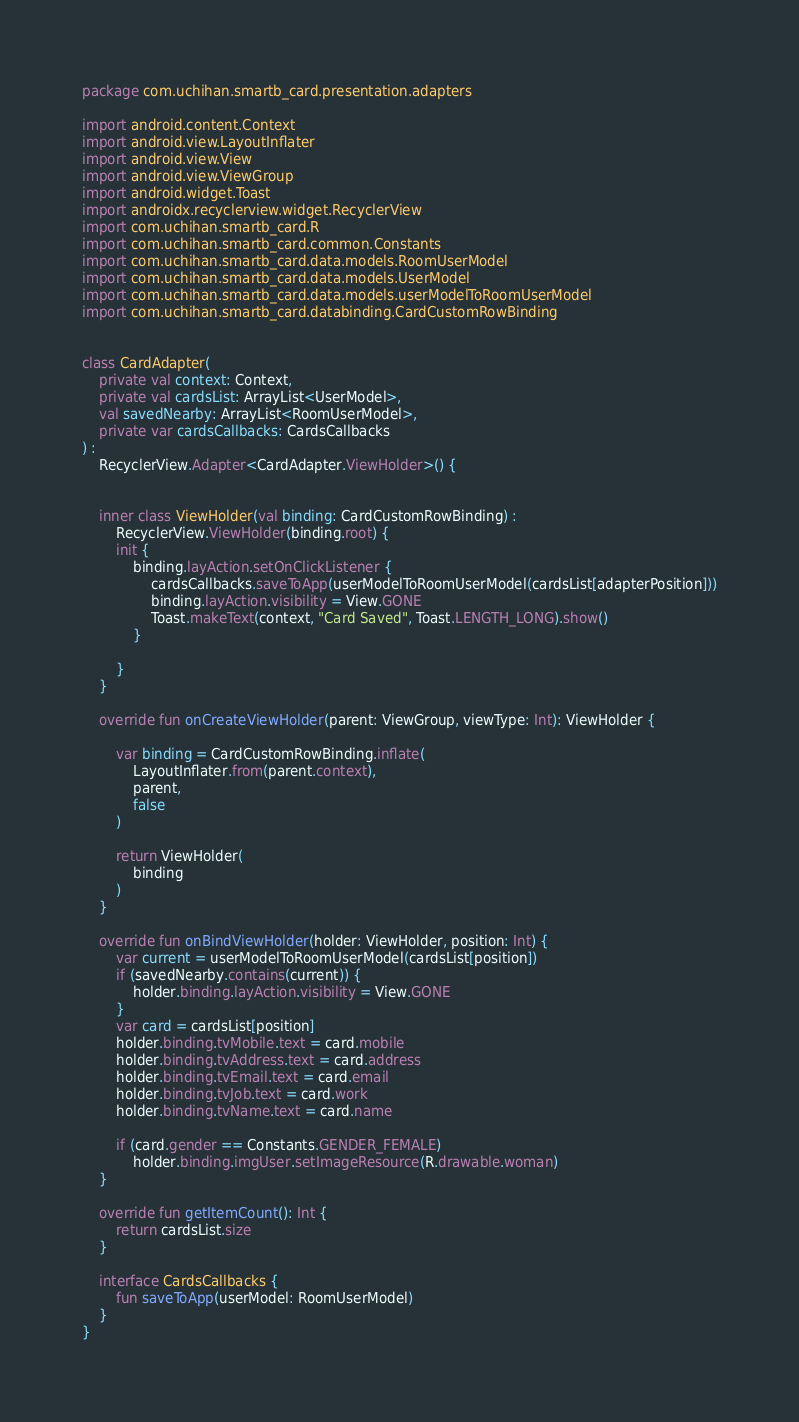<code> <loc_0><loc_0><loc_500><loc_500><_Kotlin_>package com.uchihan.smartb_card.presentation.adapters

import android.content.Context
import android.view.LayoutInflater
import android.view.View
import android.view.ViewGroup
import android.widget.Toast
import androidx.recyclerview.widget.RecyclerView
import com.uchihan.smartb_card.R
import com.uchihan.smartb_card.common.Constants
import com.uchihan.smartb_card.data.models.RoomUserModel
import com.uchihan.smartb_card.data.models.UserModel
import com.uchihan.smartb_card.data.models.userModelToRoomUserModel
import com.uchihan.smartb_card.databinding.CardCustomRowBinding


class CardAdapter(
    private val context: Context,
    private val cardsList: ArrayList<UserModel>,
    val savedNearby: ArrayList<RoomUserModel>,
    private var cardsCallbacks: CardsCallbacks
) :
    RecyclerView.Adapter<CardAdapter.ViewHolder>() {


    inner class ViewHolder(val binding: CardCustomRowBinding) :
        RecyclerView.ViewHolder(binding.root) {
        init {
            binding.layAction.setOnClickListener {
                cardsCallbacks.saveToApp(userModelToRoomUserModel(cardsList[adapterPosition]))
                binding.layAction.visibility = View.GONE
                Toast.makeText(context, "Card Saved", Toast.LENGTH_LONG).show()
            }

        }
    }

    override fun onCreateViewHolder(parent: ViewGroup, viewType: Int): ViewHolder {

        var binding = CardCustomRowBinding.inflate(
            LayoutInflater.from(parent.context),
            parent,
            false
        )

        return ViewHolder(
            binding
        )
    }

    override fun onBindViewHolder(holder: ViewHolder, position: Int) {
        var current = userModelToRoomUserModel(cardsList[position])
        if (savedNearby.contains(current)) {
            holder.binding.layAction.visibility = View.GONE
        }
        var card = cardsList[position]
        holder.binding.tvMobile.text = card.mobile
        holder.binding.tvAddress.text = card.address
        holder.binding.tvEmail.text = card.email
        holder.binding.tvJob.text = card.work
        holder.binding.tvName.text = card.name

        if (card.gender == Constants.GENDER_FEMALE)
            holder.binding.imgUser.setImageResource(R.drawable.woman)
    }

    override fun getItemCount(): Int {
        return cardsList.size
    }

    interface CardsCallbacks {
        fun saveToApp(userModel: RoomUserModel)
    }
}</code> 